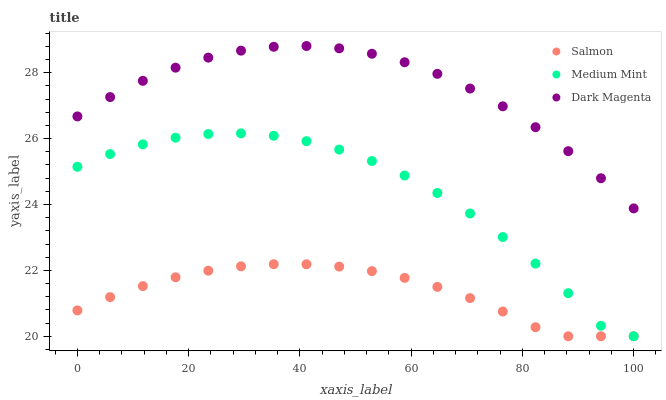Does Salmon have the minimum area under the curve?
Answer yes or no. Yes. Does Dark Magenta have the maximum area under the curve?
Answer yes or no. Yes. Does Dark Magenta have the minimum area under the curve?
Answer yes or no. No. Does Salmon have the maximum area under the curve?
Answer yes or no. No. Is Salmon the smoothest?
Answer yes or no. Yes. Is Medium Mint the roughest?
Answer yes or no. Yes. Is Dark Magenta the smoothest?
Answer yes or no. No. Is Dark Magenta the roughest?
Answer yes or no. No. Does Medium Mint have the lowest value?
Answer yes or no. Yes. Does Dark Magenta have the lowest value?
Answer yes or no. No. Does Dark Magenta have the highest value?
Answer yes or no. Yes. Does Salmon have the highest value?
Answer yes or no. No. Is Medium Mint less than Dark Magenta?
Answer yes or no. Yes. Is Dark Magenta greater than Medium Mint?
Answer yes or no. Yes. Does Salmon intersect Medium Mint?
Answer yes or no. Yes. Is Salmon less than Medium Mint?
Answer yes or no. No. Is Salmon greater than Medium Mint?
Answer yes or no. No. Does Medium Mint intersect Dark Magenta?
Answer yes or no. No. 